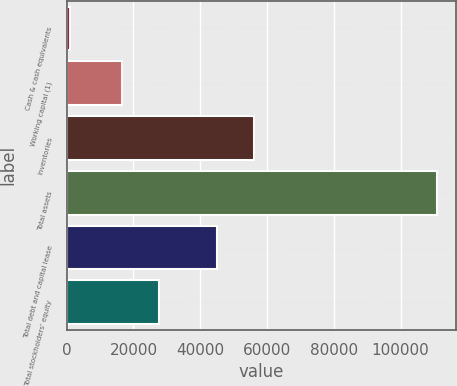<chart> <loc_0><loc_0><loc_500><loc_500><bar_chart><fcel>Cash & cash equivalents<fcel>Working capital (1)<fcel>Inventories<fcel>Total assets<fcel>Total debt and capital lease<fcel>Total stockholders' equity<nl><fcel>1085<fcel>16690<fcel>56122.2<fcel>110977<fcel>45133<fcel>27679.2<nl></chart> 